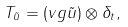<formula> <loc_0><loc_0><loc_500><loc_500>T _ { \tilde { u } } = ( { v } g \tilde { u } ) \otimes \delta _ { t } ,</formula> 